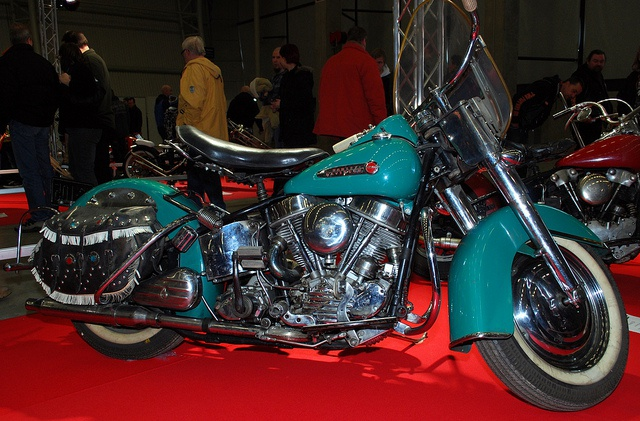Describe the objects in this image and their specific colors. I can see motorcycle in black, gray, teal, and maroon tones, motorcycle in black, maroon, gray, and darkgray tones, people in black, maroon, brown, and gray tones, people in black, maroon, teal, and gray tones, and people in black, maroon, and purple tones in this image. 